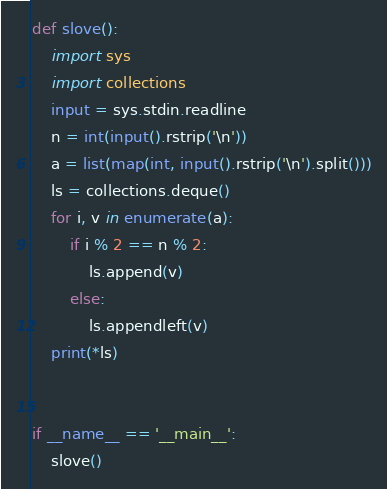Convert code to text. <code><loc_0><loc_0><loc_500><loc_500><_Python_>def slove():
    import sys
    import collections
    input = sys.stdin.readline
    n = int(input().rstrip('\n'))
    a = list(map(int, input().rstrip('\n').split()))
    ls = collections.deque()
    for i, v in enumerate(a):
        if i % 2 == n % 2:
            ls.append(v)
        else:
            ls.appendleft(v)
    print(*ls)


if __name__ == '__main__':
    slove()
</code> 